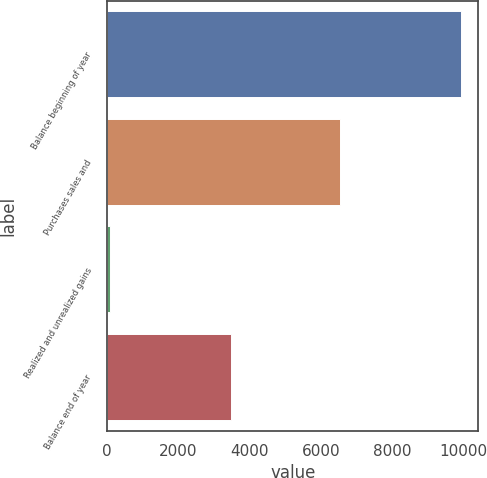Convert chart. <chart><loc_0><loc_0><loc_500><loc_500><bar_chart><fcel>Balance beginning of year<fcel>Purchases sales and<fcel>Realized and unrealized gains<fcel>Balance end of year<nl><fcel>9914<fcel>6530<fcel>93<fcel>3477<nl></chart> 